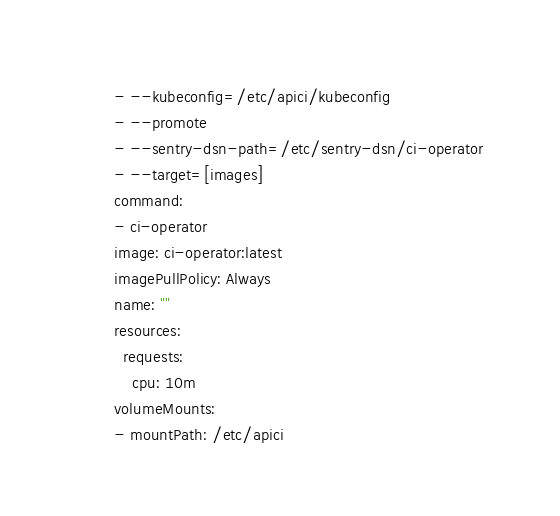<code> <loc_0><loc_0><loc_500><loc_500><_YAML_>        - --kubeconfig=/etc/apici/kubeconfig
        - --promote
        - --sentry-dsn-path=/etc/sentry-dsn/ci-operator
        - --target=[images]
        command:
        - ci-operator
        image: ci-operator:latest
        imagePullPolicy: Always
        name: ""
        resources:
          requests:
            cpu: 10m
        volumeMounts:
        - mountPath: /etc/apici</code> 